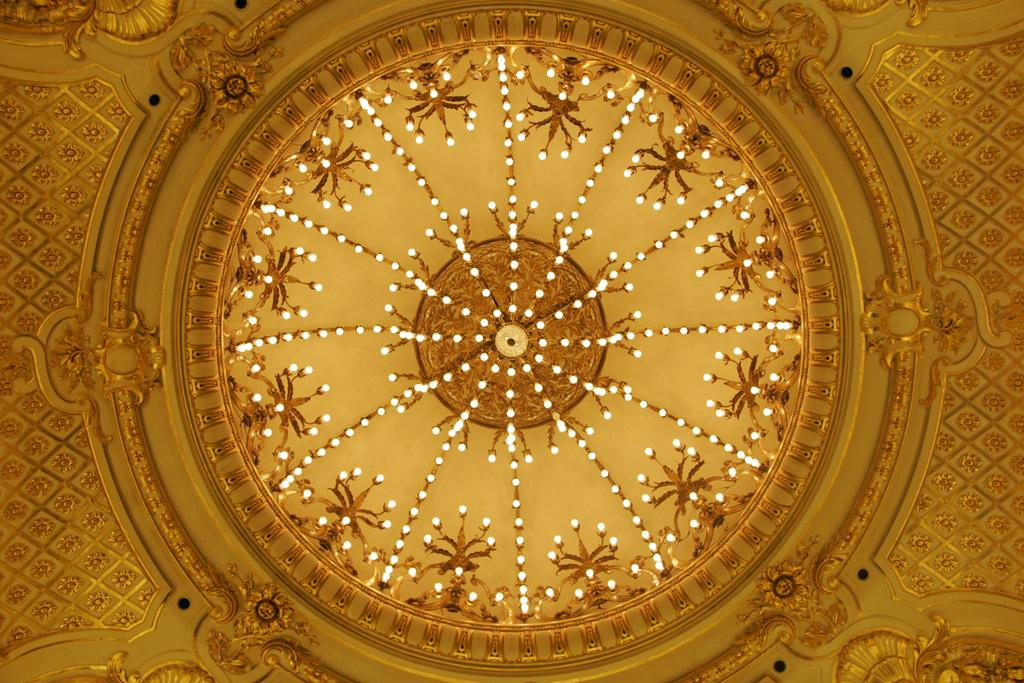What is featured on the ceiling dome in the image? There is a design on the ceiling dome in the image. Are there any other elements on the ceiling dome besides the design? Yes, there are lights on the ceiling dome in the image. What type of fiction is being read by the secretary in the image? There is no secretary or fiction present in the image; it only features a ceiling dome with a design and lights. 